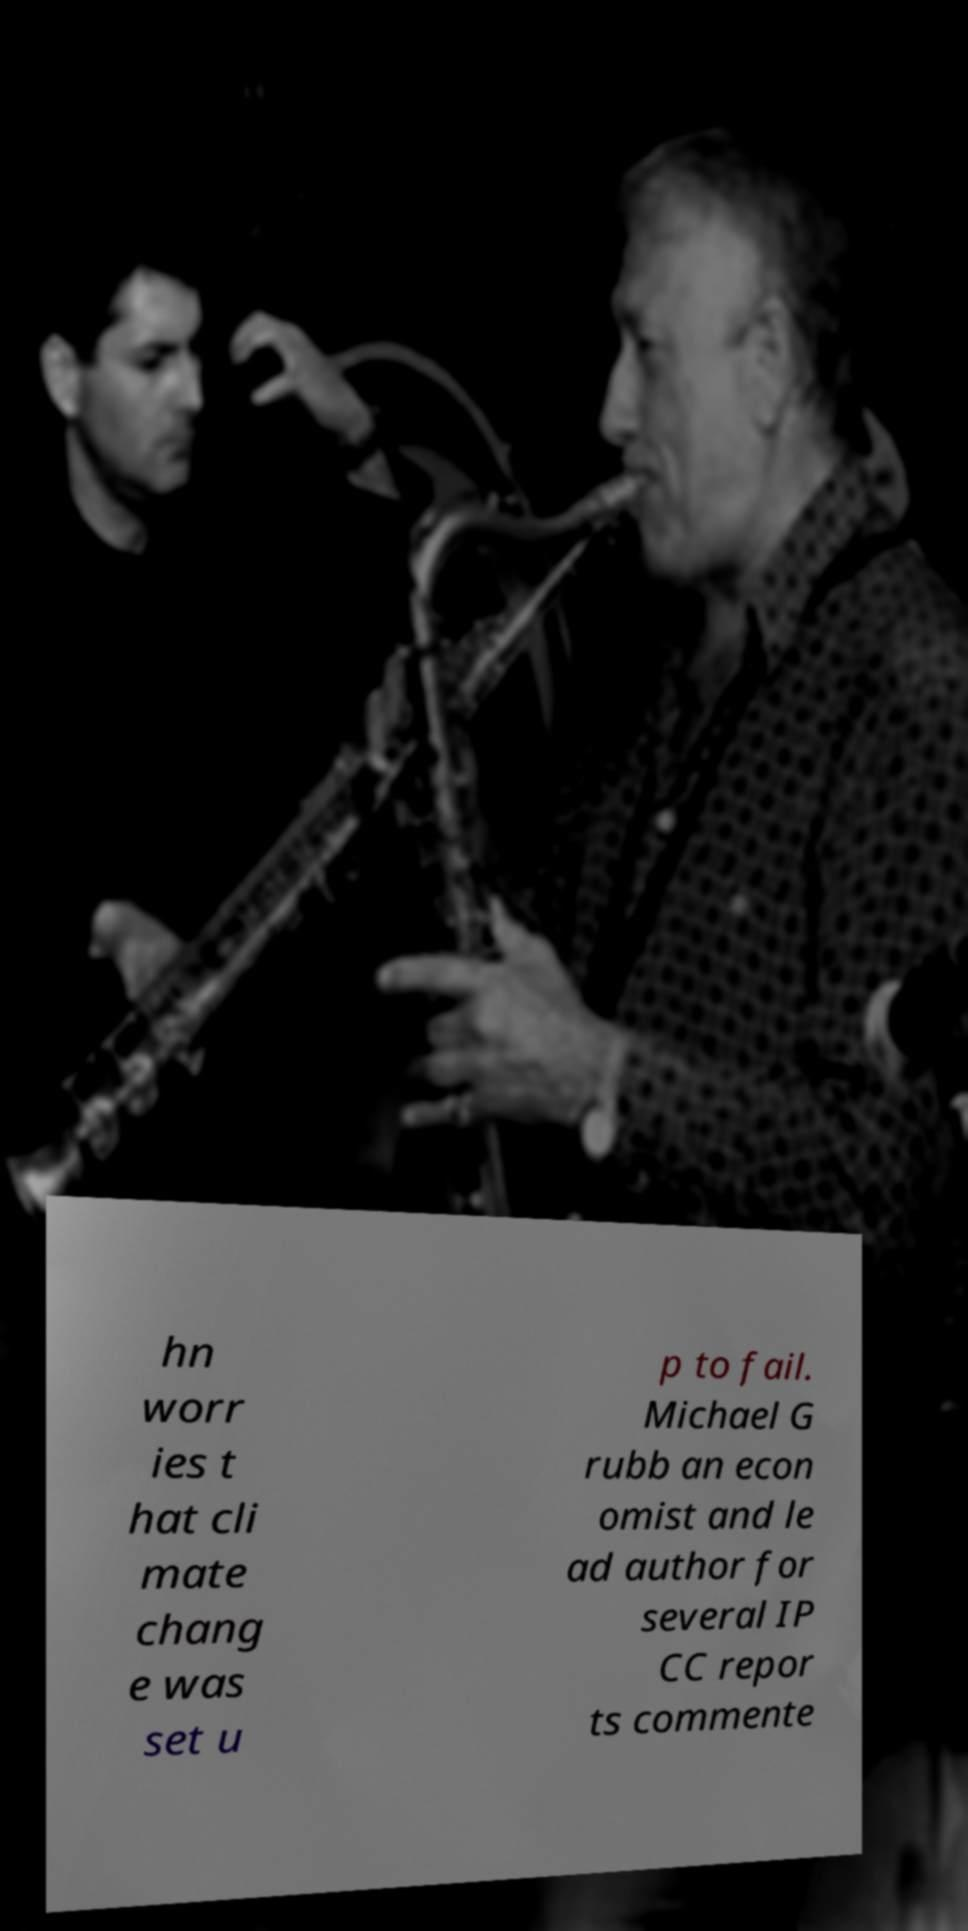Could you assist in decoding the text presented in this image and type it out clearly? hn worr ies t hat cli mate chang e was set u p to fail. Michael G rubb an econ omist and le ad author for several IP CC repor ts commente 